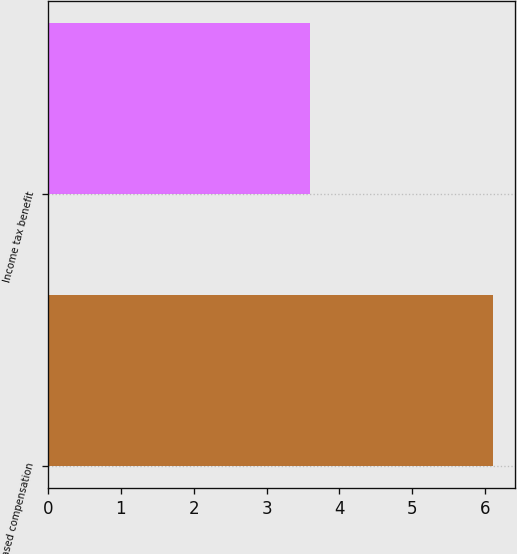<chart> <loc_0><loc_0><loc_500><loc_500><bar_chart><fcel>Stock-based compensation<fcel>Income tax benefit<nl><fcel>6.1<fcel>3.6<nl></chart> 